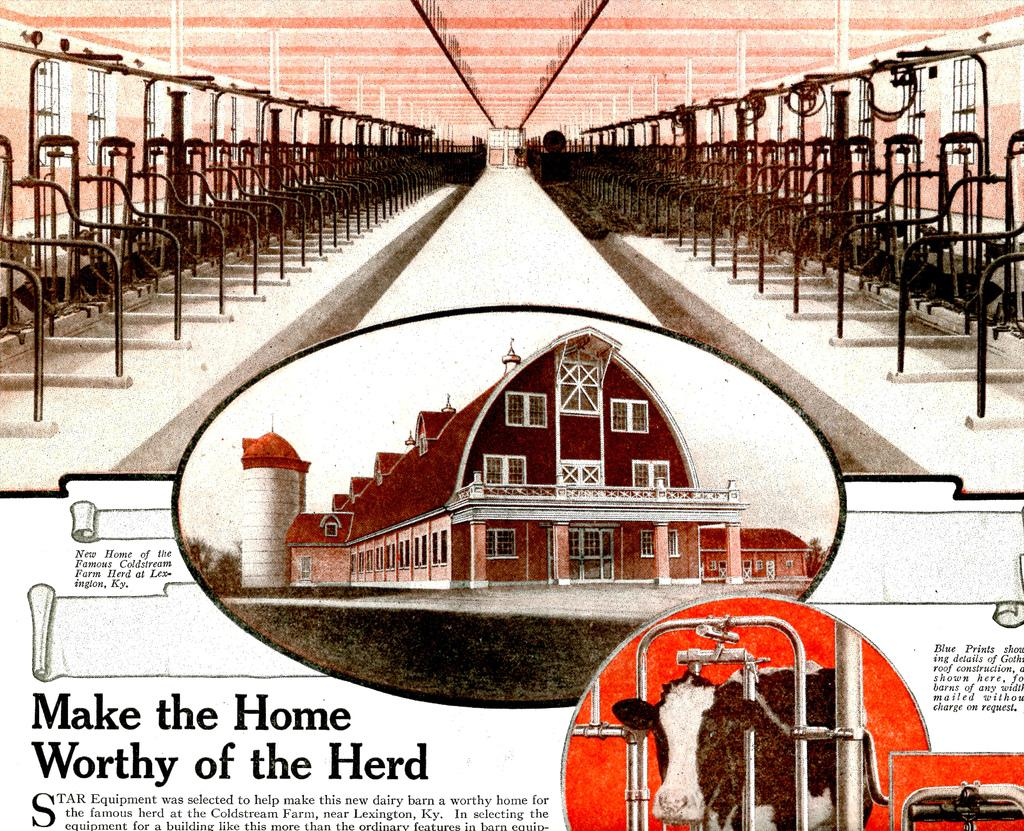<image>
Share a concise interpretation of the image provided. An indoor and outdoor picture of a barn with an article about the herd below it. 